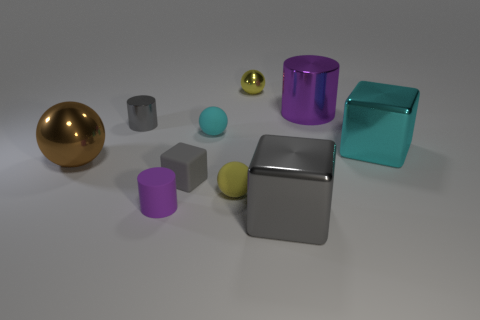Subtract all brown spheres. How many spheres are left? 3 Subtract all gray cylinders. How many cylinders are left? 2 Subtract all spheres. How many objects are left? 6 Subtract 2 cylinders. How many cylinders are left? 1 Subtract all yellow blocks. Subtract all brown spheres. How many blocks are left? 3 Subtract all gray spheres. How many green cylinders are left? 0 Subtract all tiny cyan matte objects. Subtract all cyan shiny cubes. How many objects are left? 8 Add 8 brown metal balls. How many brown metal balls are left? 9 Add 3 yellow metallic objects. How many yellow metallic objects exist? 4 Subtract 1 cyan balls. How many objects are left? 9 